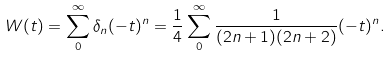<formula> <loc_0><loc_0><loc_500><loc_500>W ( t ) = \sum ^ { \infty } _ { 0 } \delta _ { n } ( - t ) ^ { n } = \frac { 1 } { 4 } \sum ^ { \infty } _ { 0 } \frac { 1 } { ( 2 n + 1 ) ( 2 n + 2 ) } ( - t ) ^ { n } .</formula> 